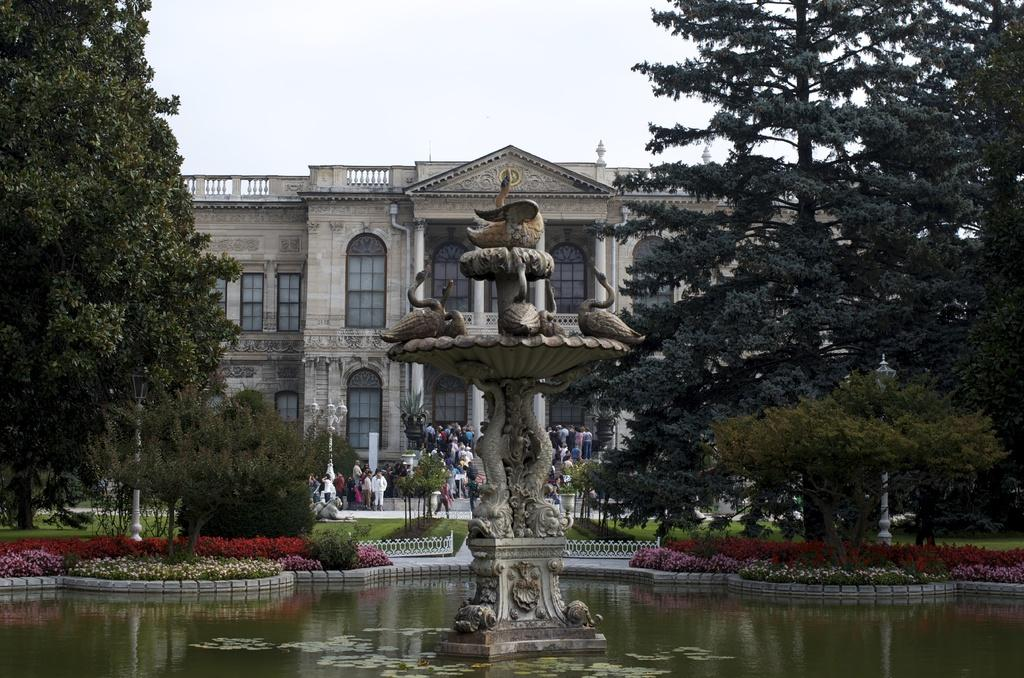What is the main feature in the image? There is a fountain in the image. What is present in the fountain? There is water in the image. What can be seen in the background of the image? There is a building, people, trees, and the sky visible in the background of the image. What is the size of the page in the image? There is no page present in the image. Can you describe the kick of the person in the image? There are no people kicking in the image; the people in the background are not engaged in any such activity. 